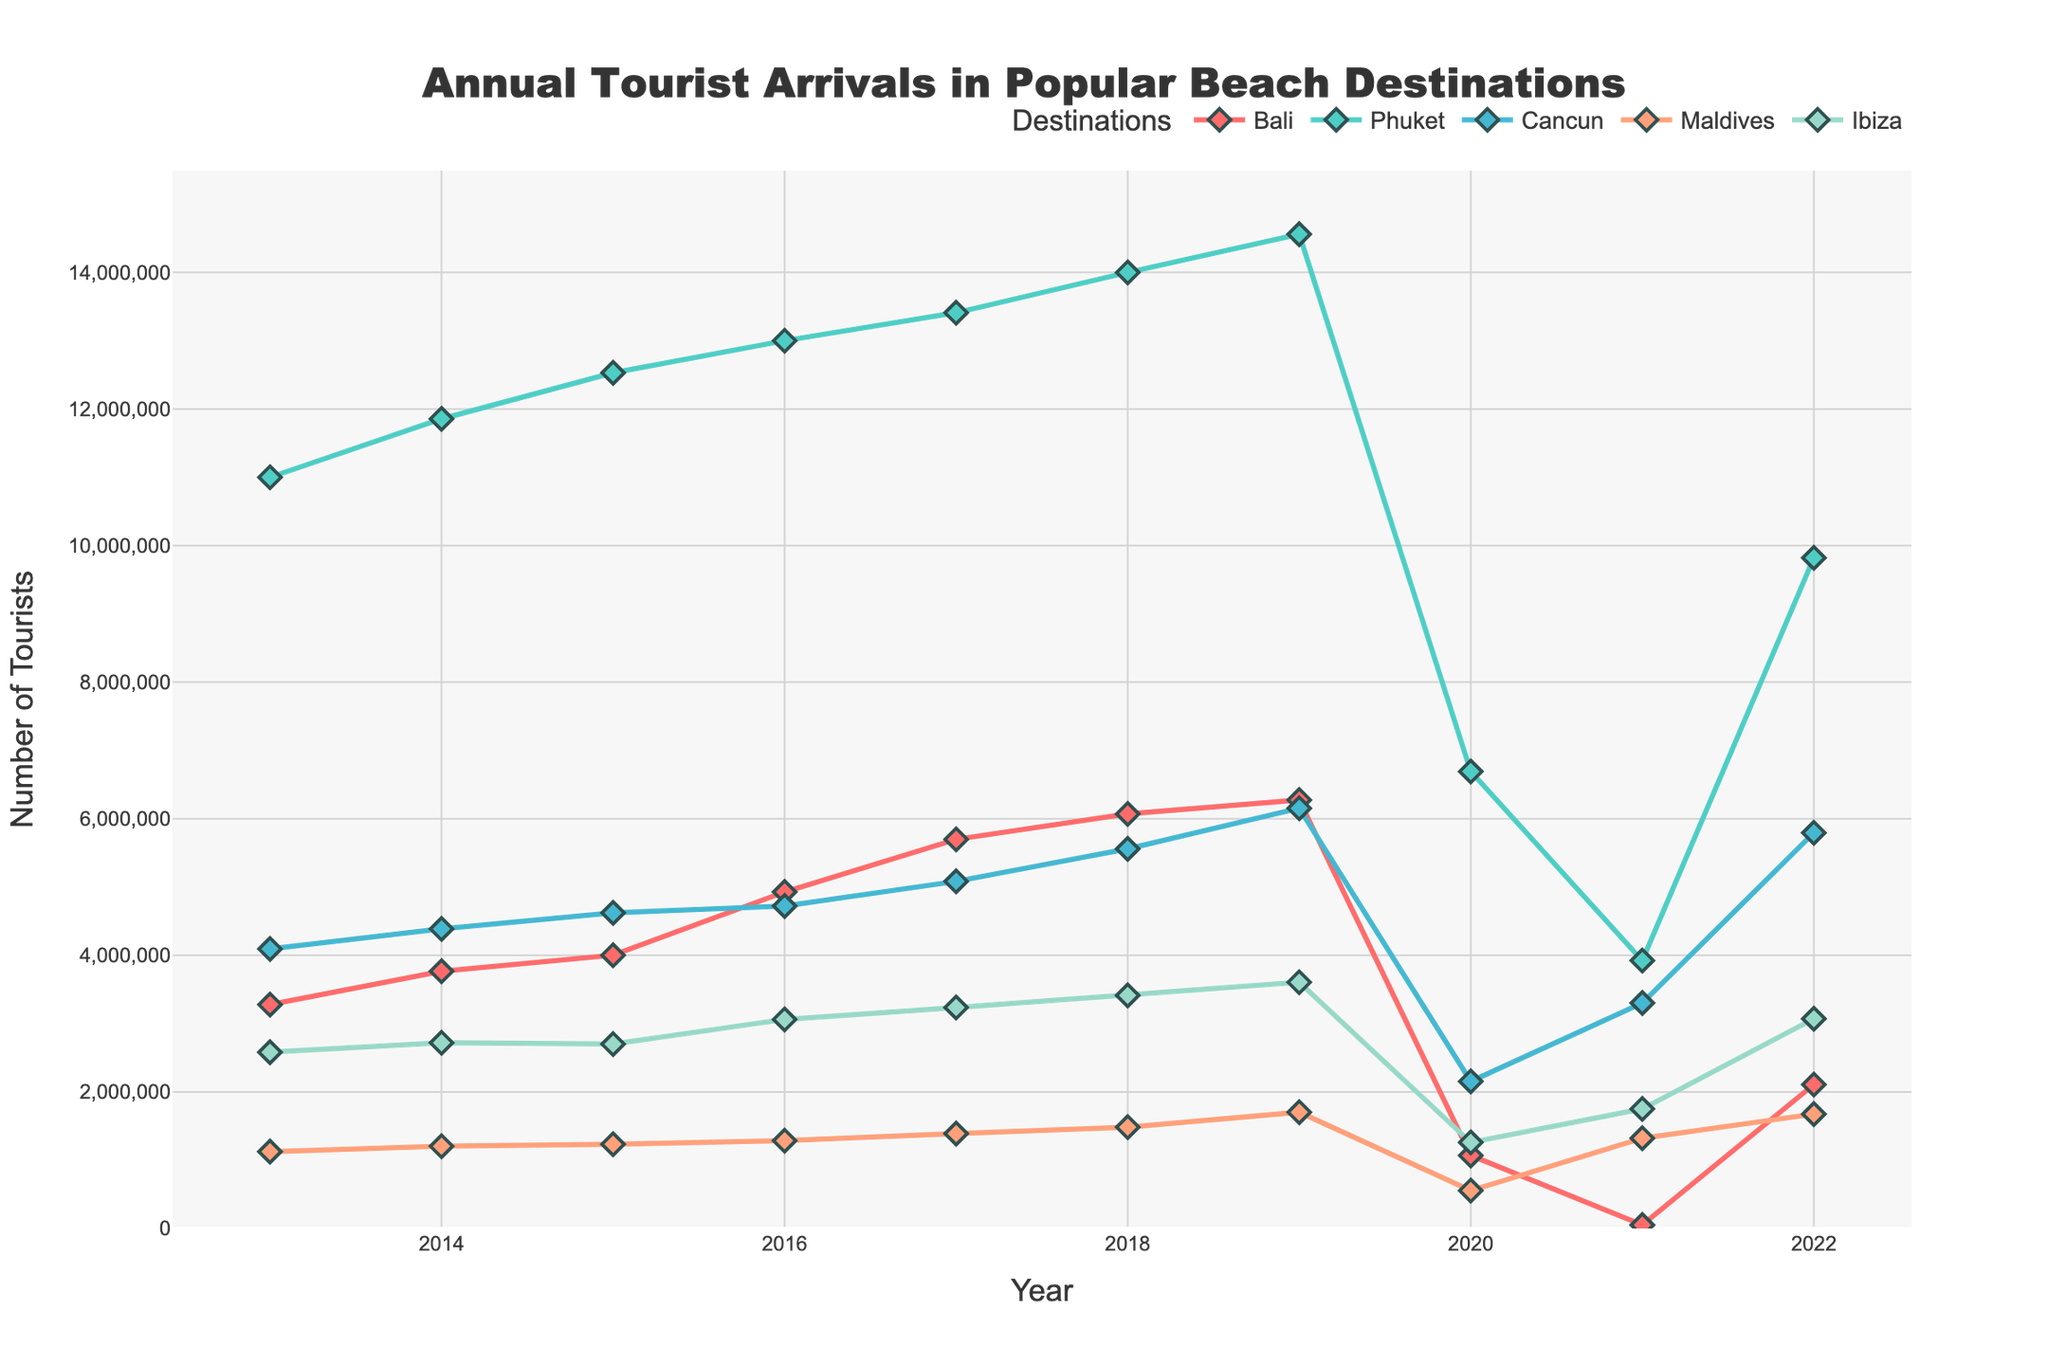What's the trend in tourist arrivals for Bali from 2013 to 2022? The figure shows the number of tourists visiting Bali each year. Observing the line for Bali, we can see that the overall trend is upward until 2019, after which there was a significant drop in 2020, followed by a fluctuating recovery in 2021 and 2022.
Answer: Upward until 2019, then a significant drop, followed by recovery Which destination had the highest number of tourist arrivals in 2019? By looking at the highest points on the graph for 2019, we see that Phuket had the highest number of tourist arrivals, as indicated by the green line reaching the peak value.
Answer: Phuket In which year did Maldives see the highest number of tourist arrivals? By tracing the line for Maldives, which is shown in pink, we find its peak at the highest value in 2019.
Answer: 2019 What was the combined number of tourists for all five destinations in 2020? To calculate the combined number, we need to sum up the values for all destinations in 2020: Bali (1,069,473) + Phuket (6,692,000) + Cancun (2,154,319) + Maldives (555,494) + Ibiza (1,260,832). The sum is 1,069,473 + 6,692,000 + 2,154,319 + 555,494 + 1,260,832 = 11,732,118.
Answer: 11,732,118 How did the tourist arrival numbers for Cancun change from 2016 to 2017, and what might this indicate? For Cancun, the values are 4,722,286 in 2016 and 5,083,239 in 2017. Observing the change: 5,083,239 - 4,722,286 = 360,953, an increase in tourist arrivals. This indicates growth in popularity or better accessibility during this period.
Answer: Increased by 360,953 Which destination showed the quickest recovery in tourist numbers from 2020 to 2022? By comparing the slopes or differences for each destination from 2020 to 2022, we see that Ibiza shows a noticeable increase from the 2020 low. Specifically, it grows from 1,260,832 in 2020 to 3,071,699 in 2022, a jump of 1,810,867, which seems the most substantial among all.
Answer: Ibiza What impact did 2020 have on all five destinations, visually speaking? Visually, the impact of 2020 is significant as all lines drop dramatically from 2019 to 2020, representing a sharp decline in tourist arrivals due to global travel restrictions.
Answer: Sharp decline for all How do the tourist numbers for Phuket in 2021 compare to those in 2022? Observing the green line for Phuket, the number of tourists in 2021 is 3,923,000 and in 2022 is 9,820,000. Therefore, the tourist arrivals in 2022 are significantly higher than in 2021 by 5,897,000.
Answer: 5,897,000 higher in 2022 Which destination had the most stable tourist numbers from 2013 to 2019, excluding any drops? By examining the lines for all destinations from 2013 to 2019, Ibiza generally shows a consistent upward trend with fewer fluctuations, indicating more stable growth compared to others.
Answer: Ibiza Comparing Bali and Ibiza, in which year did both have similar tourist arrival numbers? By closely inspecting the points on the lines for Bali and Ibiza, they both have similar tourist numbers in 2016, where Bali is at 4,927,937 and Ibiza is at 3,061,787, showing the closest tight crowd.
Answer: 2016 